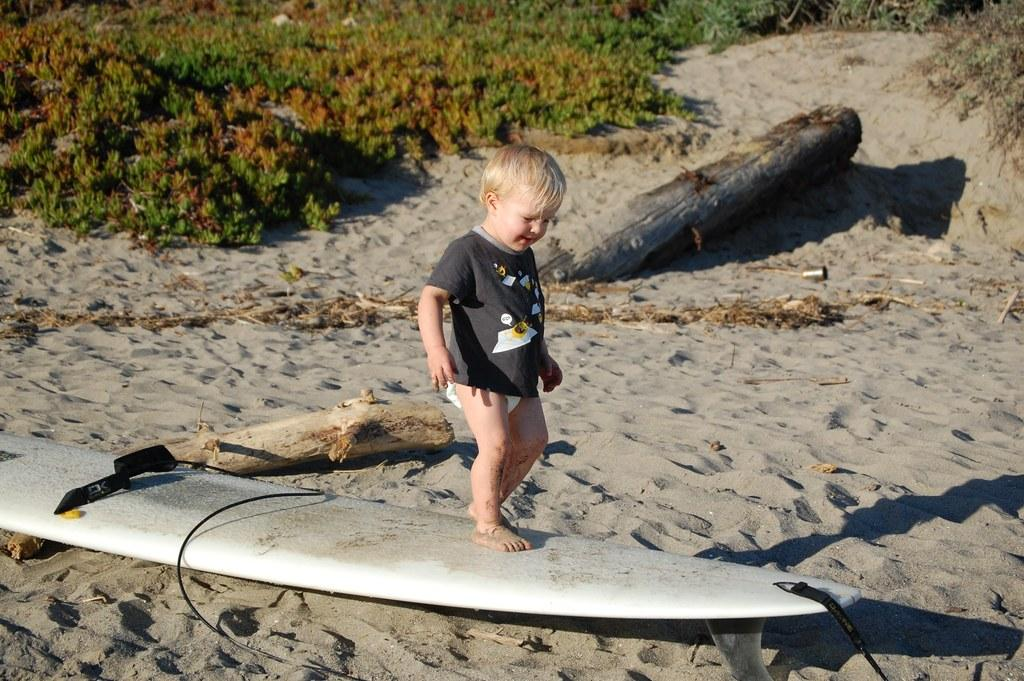Who is the main subject in the image? There is a little boy in the image. What is the boy doing in the image? The boy is standing on a surfing board. Where is the surfing board located? The surfing board is on the surface of the sand. What objects can be seen behind the boy? There are two wooden sticks behind the boy. What type of vegetation is present in the image? Grass is present in the image. What type of cherries can be seen floating in the soup in the image? There are no cherries or soup present in the image; it features a little boy standing on a surfing board on the sand with wooden sticks behind him and grass nearby. 